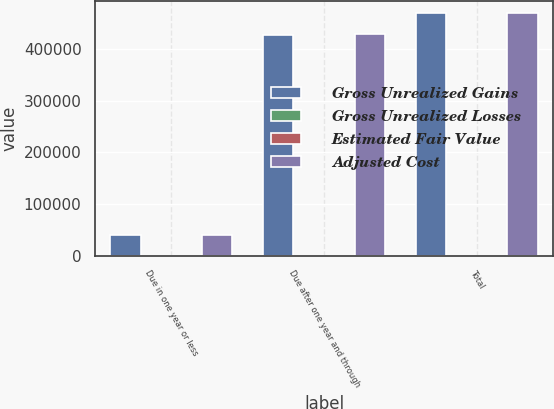Convert chart. <chart><loc_0><loc_0><loc_500><loc_500><stacked_bar_chart><ecel><fcel>Due in one year or less<fcel>Due after one year and through<fcel>Total<nl><fcel>Gross Unrealized Gains<fcel>41078<fcel>428212<fcel>469290<nl><fcel>Gross Unrealized Losses<fcel>5<fcel>434<fcel>439<nl><fcel>Estimated Fair Value<fcel>5<fcel>94<fcel>99<nl><fcel>Adjusted Cost<fcel>41078<fcel>428552<fcel>469630<nl></chart> 